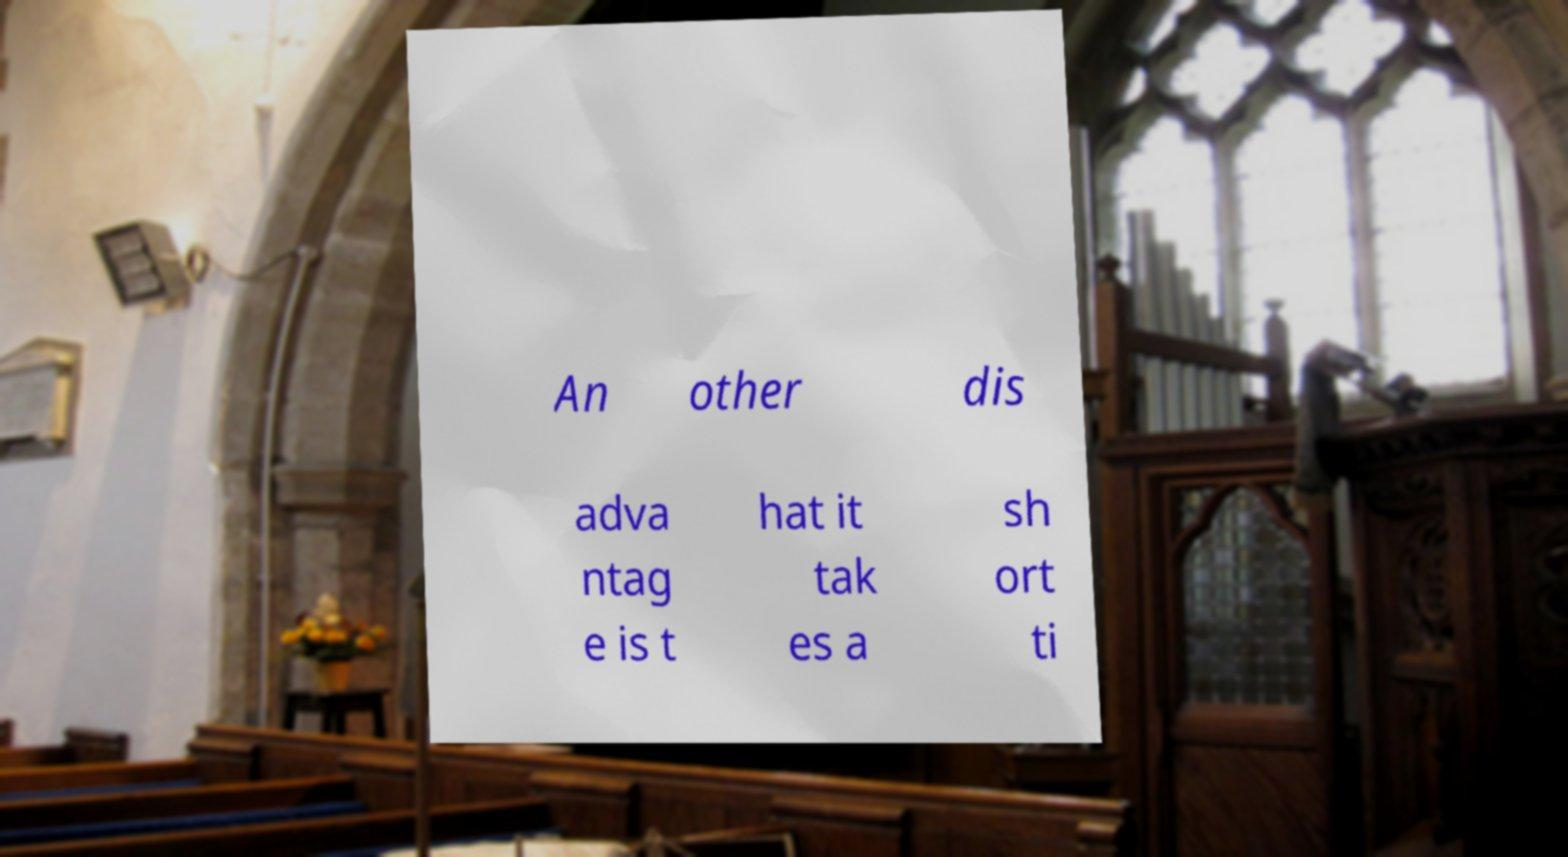What messages or text are displayed in this image? I need them in a readable, typed format. An other dis adva ntag e is t hat it tak es a sh ort ti 